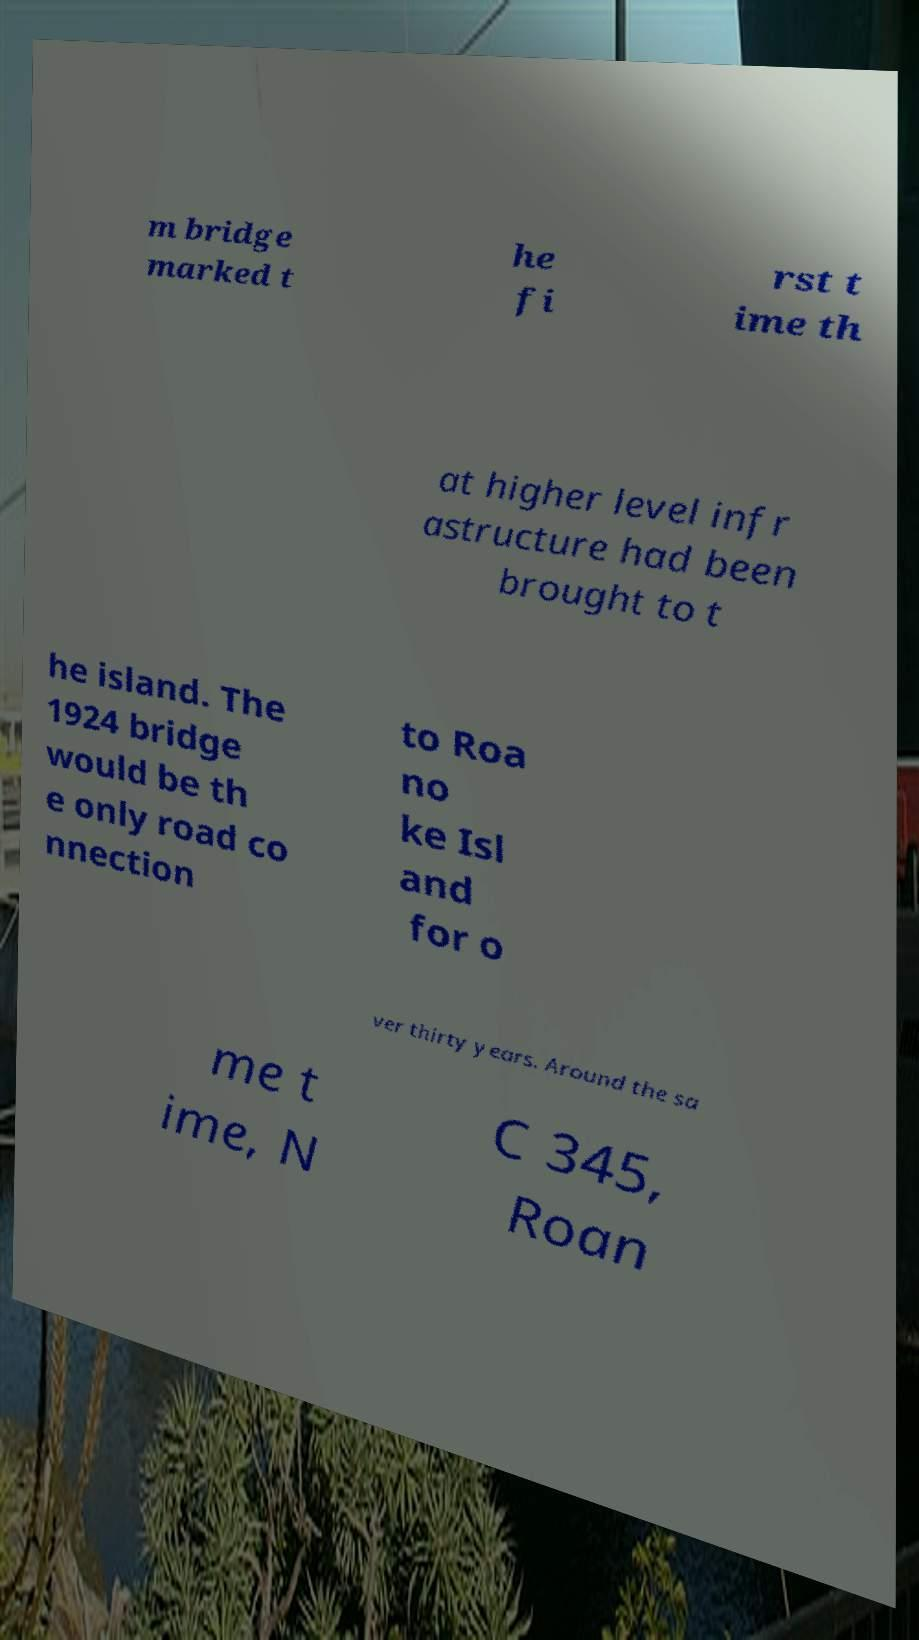Can you accurately transcribe the text from the provided image for me? m bridge marked t he fi rst t ime th at higher level infr astructure had been brought to t he island. The 1924 bridge would be th e only road co nnection to Roa no ke Isl and for o ver thirty years. Around the sa me t ime, N C 345, Roan 